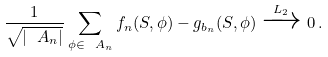<formula> <loc_0><loc_0><loc_500><loc_500>\frac { 1 } { \sqrt { | \ A _ { n } | } } \sum _ { \phi \in \ A _ { n } } f _ { n } ( S , \phi ) - g _ { b _ { n } } ( S , \phi ) \xrightarrow { L _ { 2 } } 0 \, .</formula> 